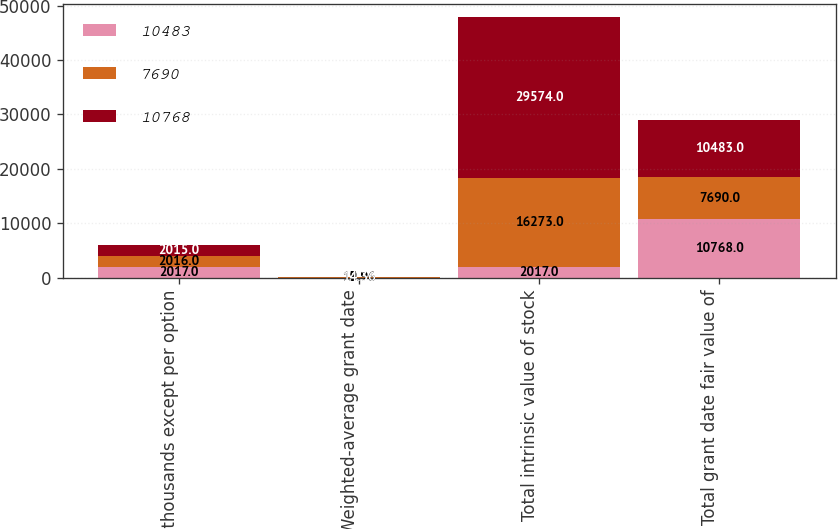Convert chart. <chart><loc_0><loc_0><loc_500><loc_500><stacked_bar_chart><ecel><fcel>in thousands except per option<fcel>Weighted-average grant date<fcel>Total intrinsic value of stock<fcel>Total grant date fair value of<nl><fcel>10483<fcel>2017<fcel>19.96<fcel>2017<fcel>10768<nl><fcel>7690<fcel>2016<fcel>13.96<fcel>16273<fcel>7690<nl><fcel>10768<fcel>2015<fcel>14.36<fcel>29574<fcel>10483<nl></chart> 